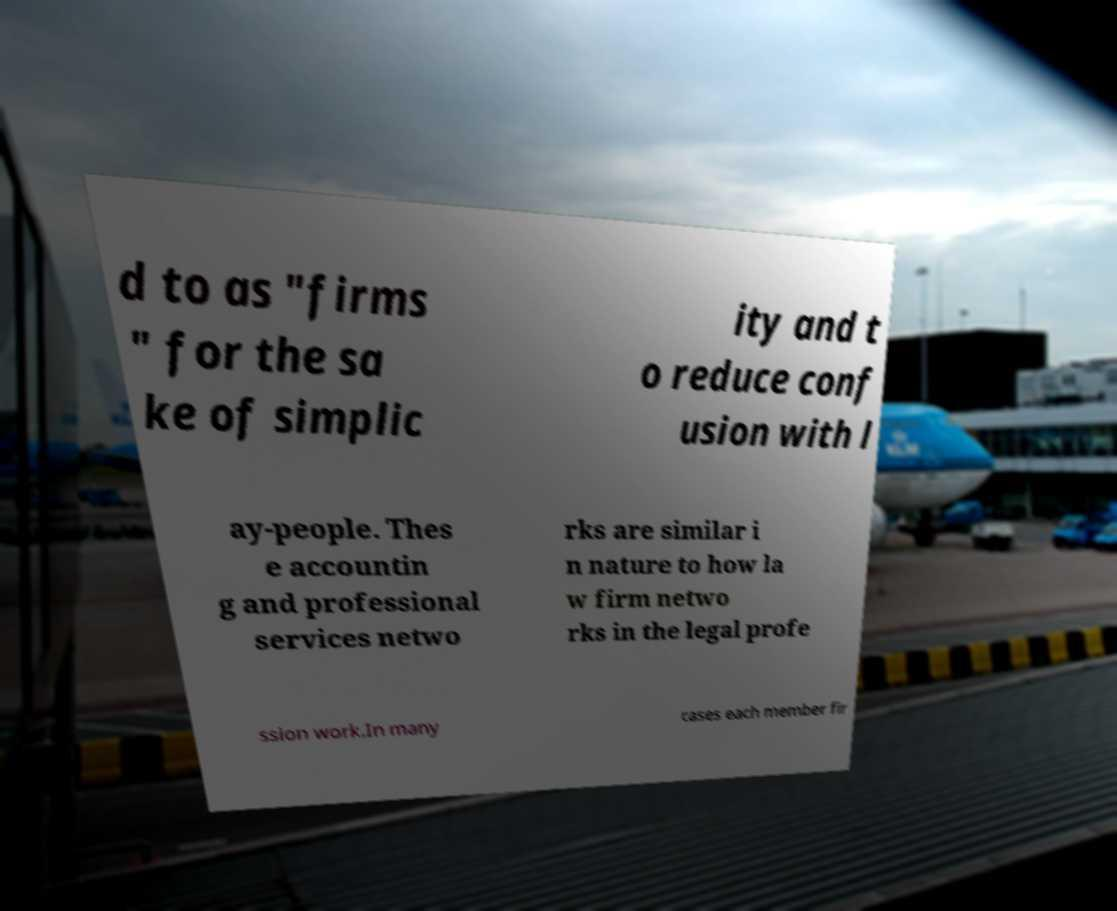Can you accurately transcribe the text from the provided image for me? d to as "firms " for the sa ke of simplic ity and t o reduce conf usion with l ay-people. Thes e accountin g and professional services netwo rks are similar i n nature to how la w firm netwo rks in the legal profe ssion work.In many cases each member fir 